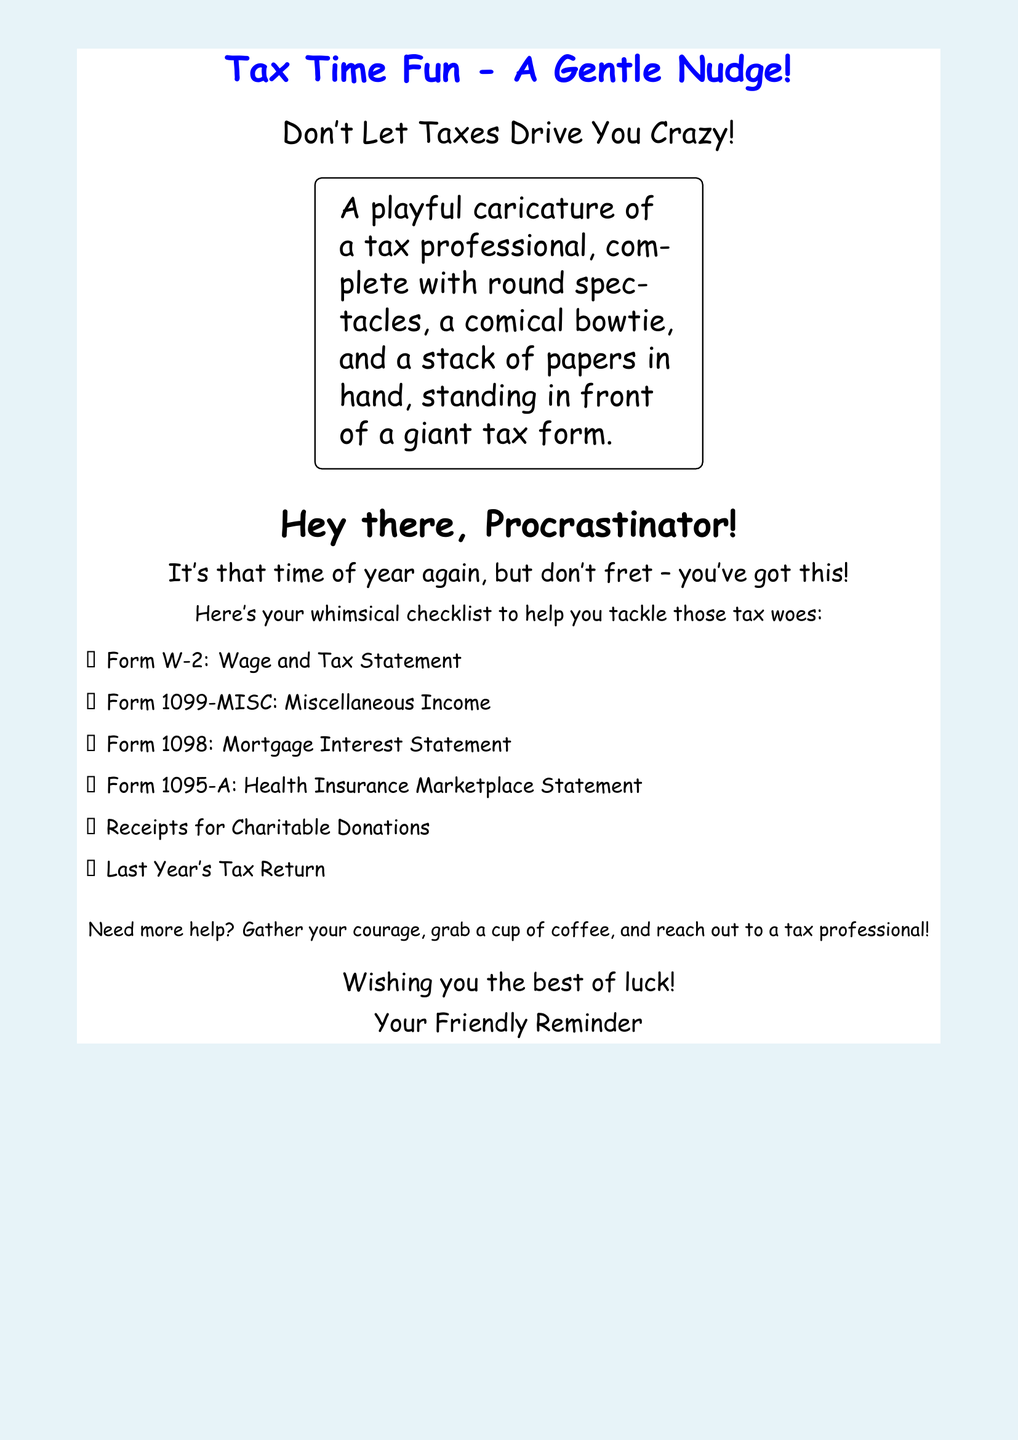What is the title of the greeting card? The title is prominently displayed at the top of the card, emphasizing its playful intent.
Answer: Tax Time Fun - A Gentle Nudge! What color is the background of the document? The background color is described as light blue and provides a cheerful contrast to the text.
Answer: Light blue How many items are listed in the checklist? The document contains a checklist that helps the reader remember important tax documents.
Answer: Six What is the first item on the checklist? The first item on the checklist is a common tax form that many individuals receive from their employers.
Answer: Form W-2: Wage and Tax Statement What type of character is illustrated in the document? The document features a whimsical character that provides a lighthearted tone to the serious subject of taxes.
Answer: Tax professional What is suggested to help with tax-related stress? The card offers encouragement and practical advice to handle tax preparation.
Answer: Gather your courage, grab a cup of coffee, and reach out to a tax professional! What is the closing sentiment of the card? The final message on the card aims to uplift the recipient as they face their taxes.
Answer: Wishing you the best of luck! 